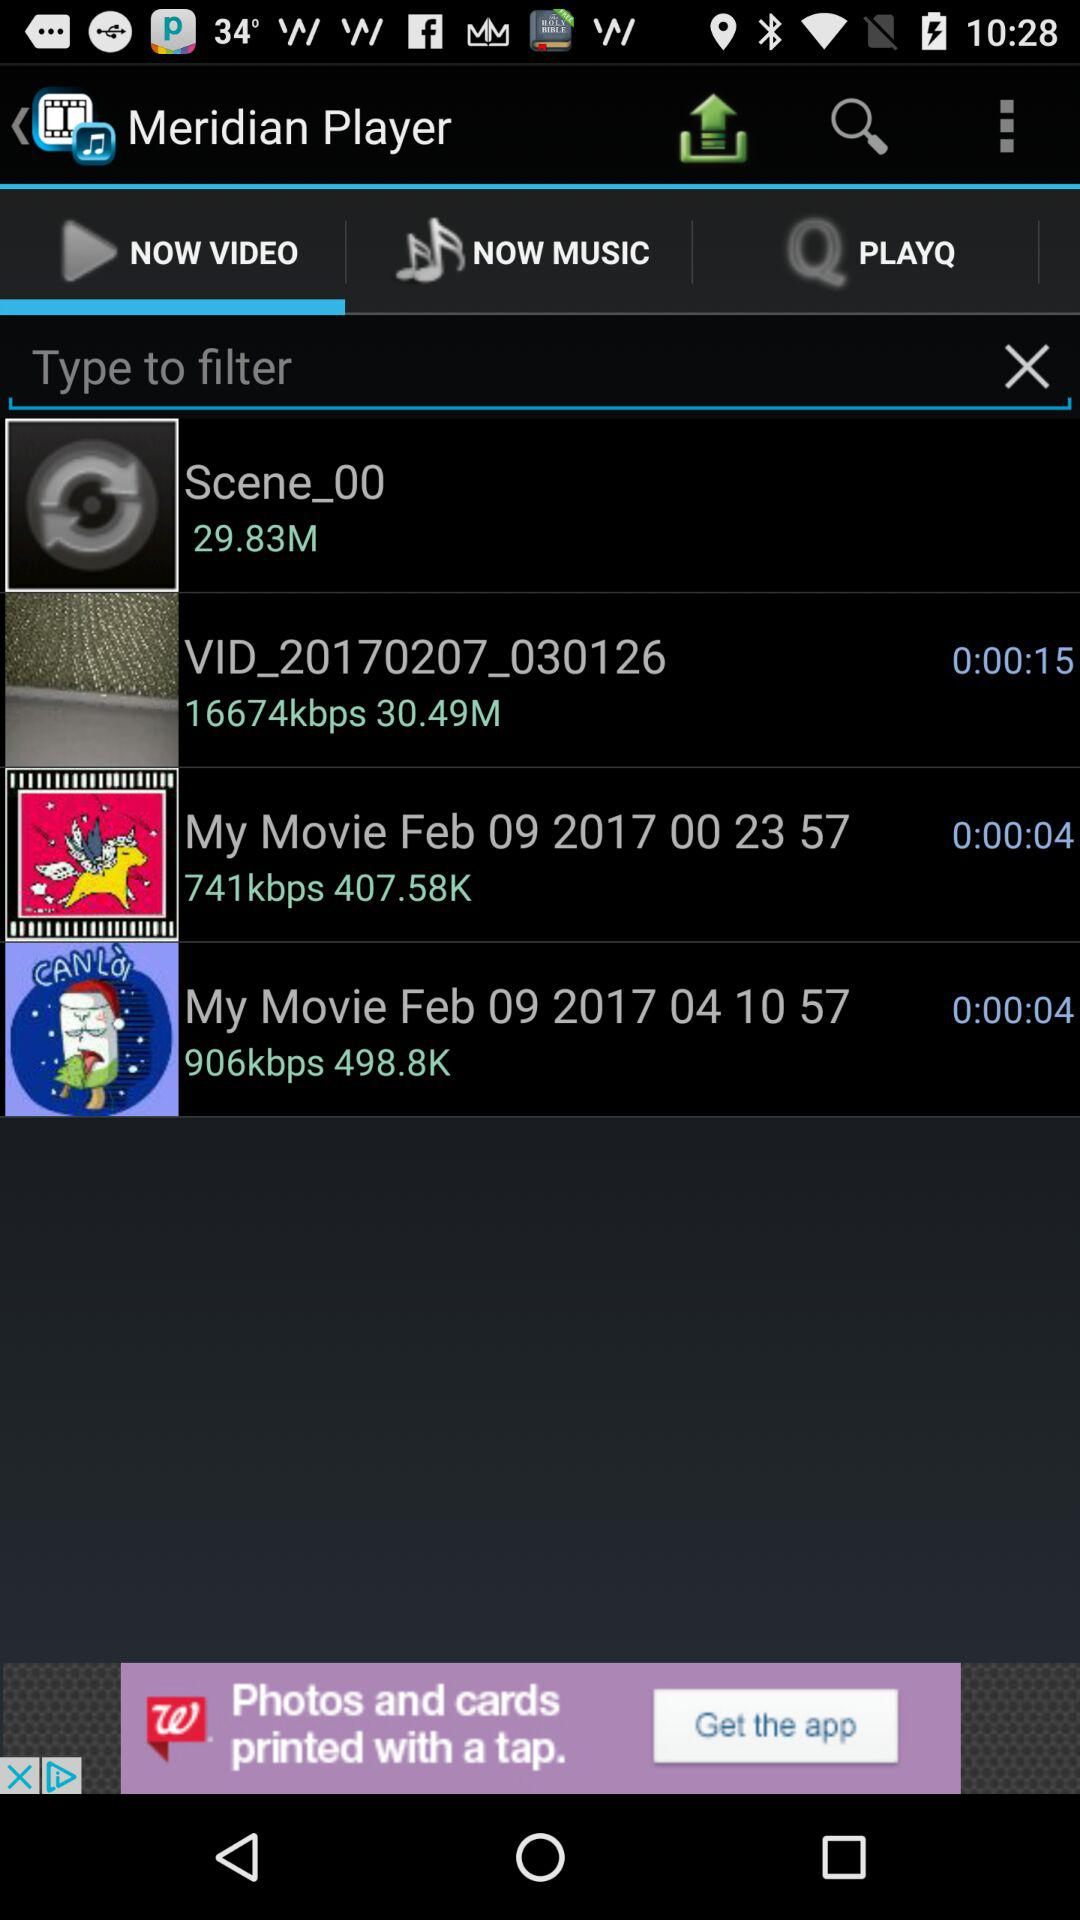What's the length of the video "VID_20170207_030126"? The length of the video is 15 seconds. 